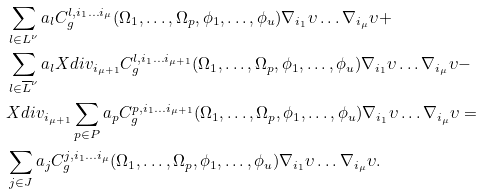Convert formula to latex. <formula><loc_0><loc_0><loc_500><loc_500>& \sum _ { l \in L ^ { \nu } } a _ { l } C ^ { l , i _ { 1 } \dots i _ { \mu } } _ { g } ( \Omega _ { 1 } , \dots , \Omega _ { p } , \phi _ { 1 } , \dots , \phi _ { u } ) \nabla _ { i _ { 1 } } \upsilon \dots \nabla _ { i _ { \mu } } \upsilon + \\ & \sum _ { l \in \overline { L } ^ { \nu } } a _ { l } X d i v _ { i _ { \mu + 1 } } C ^ { l , i _ { 1 } \dots i _ { \mu + 1 } } _ { g } ( \Omega _ { 1 } , \dots , \Omega _ { p } , \phi _ { 1 } , \dots , \phi _ { u } ) \nabla _ { i _ { 1 } } \upsilon \dots \nabla _ { i _ { \mu } } \upsilon - \\ & X d i v _ { i _ { \mu + 1 } } \sum _ { p \in P } a _ { p } C ^ { p , i _ { 1 } \dots i _ { \mu + 1 } } _ { g } ( \Omega _ { 1 } , \dots , \Omega _ { p } , \phi _ { 1 } , \dots , \phi _ { u } ) \nabla _ { i _ { 1 } } \upsilon \dots \nabla _ { i _ { \mu } } \upsilon = \\ & \sum _ { j \in J } a _ { j } C ^ { j , i _ { 1 } \dots i _ { \mu } } _ { g } ( \Omega _ { 1 } , \dots , \Omega _ { p } , \phi _ { 1 } , \dots , \phi _ { u } ) \nabla _ { i _ { 1 } } \upsilon \dots \nabla _ { i _ { \mu } } \upsilon .</formula> 